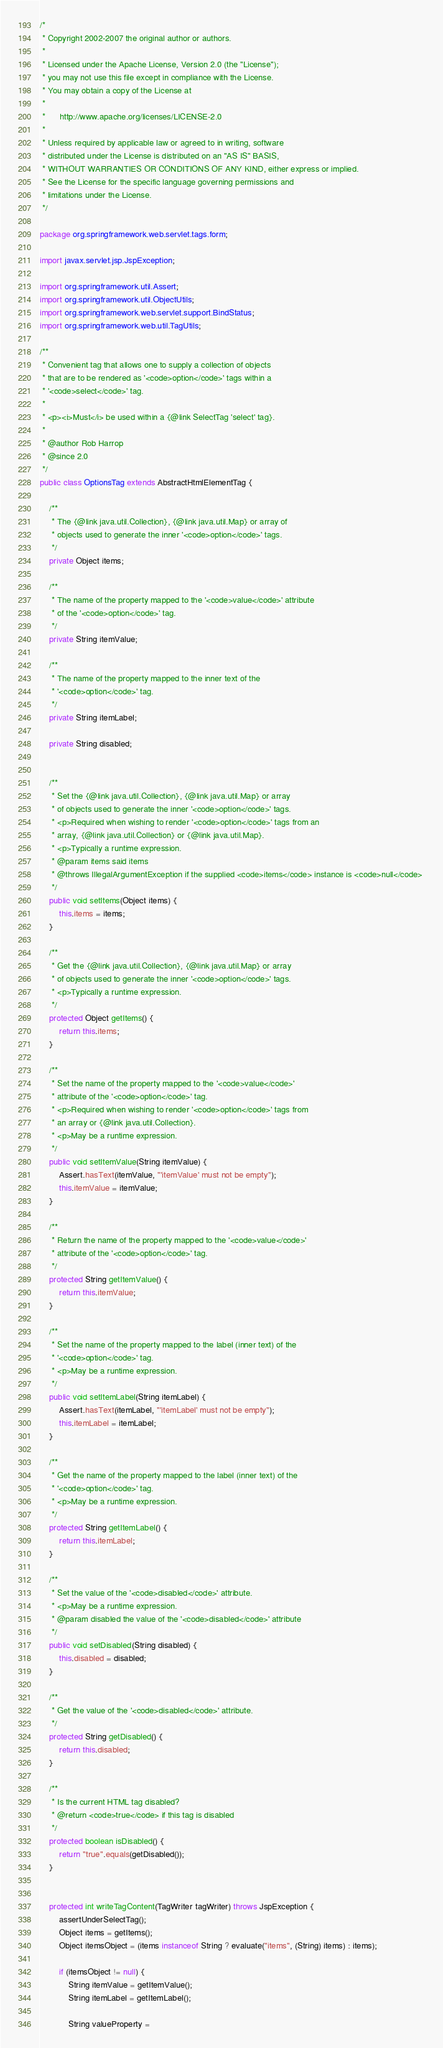<code> <loc_0><loc_0><loc_500><loc_500><_Java_>/*
 * Copyright 2002-2007 the original author or authors.
 *
 * Licensed under the Apache License, Version 2.0 (the "License");
 * you may not use this file except in compliance with the License.
 * You may obtain a copy of the License at
 *
 *      http://www.apache.org/licenses/LICENSE-2.0
 *
 * Unless required by applicable law or agreed to in writing, software
 * distributed under the License is distributed on an "AS IS" BASIS,
 * WITHOUT WARRANTIES OR CONDITIONS OF ANY KIND, either express or implied.
 * See the License for the specific language governing permissions and
 * limitations under the License.
 */

package org.springframework.web.servlet.tags.form;

import javax.servlet.jsp.JspException;

import org.springframework.util.Assert;
import org.springframework.util.ObjectUtils;
import org.springframework.web.servlet.support.BindStatus;
import org.springframework.web.util.TagUtils;

/**
 * Convenient tag that allows one to supply a collection of objects
 * that are to be rendered as '<code>option</code>' tags within a
 * '<code>select</code>' tag.
 * 
 * <p><i>Must</i> be used within a {@link SelectTag 'select' tag}.
 * 
 * @author Rob Harrop
 * @since 2.0
 */
public class OptionsTag extends AbstractHtmlElementTag {
	
	/**
	 * The {@link java.util.Collection}, {@link java.util.Map} or array of
	 * objects used to generate the inner '<code>option</code>' tags.
	 */
	private Object items;

	/**
	 * The name of the property mapped to the '<code>value</code>' attribute
	 * of the '<code>option</code>' tag.
	 */
	private String itemValue;

	/**
	 * The name of the property mapped to the inner text of the
	 * '<code>option</code>' tag.
	 */
	private String itemLabel;

	private String disabled;


	/**
	 * Set the {@link java.util.Collection}, {@link java.util.Map} or array
	 * of objects used to generate the inner '<code>option</code>' tags.
	 * <p>Required when wishing to render '<code>option</code>' tags from an
	 * array, {@link java.util.Collection} or {@link java.util.Map}.
	 * <p>Typically a runtime expression.
	 * @param items said items
	 * @throws IllegalArgumentException if the supplied <code>items</code> instance is <code>null</code> 
	 */
	public void setItems(Object items) {
		this.items = items;
	}

	/**
	 * Get the {@link java.util.Collection}, {@link java.util.Map} or array
	 * of objects used to generate the inner '<code>option</code>' tags.
	 * <p>Typically a runtime expression.
	 */
	protected Object getItems() {
		return this.items;
	}

	/**
	 * Set the name of the property mapped to the '<code>value</code>'
	 * attribute of the '<code>option</code>' tag.
	 * <p>Required when wishing to render '<code>option</code>' tags from
	 * an array or {@link java.util.Collection}.
	 * <p>May be a runtime expression.
	 */
	public void setItemValue(String itemValue) {
		Assert.hasText(itemValue, "'itemValue' must not be empty");
		this.itemValue = itemValue;
	}

	/**
	 * Return the name of the property mapped to the '<code>value</code>'
	 * attribute of the '<code>option</code>' tag.
	 */
	protected String getItemValue() {
		return this.itemValue;
	}

	/**
	 * Set the name of the property mapped to the label (inner text) of the
	 * '<code>option</code>' tag.
	 * <p>May be a runtime expression.
	 */
	public void setItemLabel(String itemLabel) {
		Assert.hasText(itemLabel, "'itemLabel' must not be empty");
		this.itemLabel = itemLabel;
	}

	/**
	 * Get the name of the property mapped to the label (inner text) of the
	 * '<code>option</code>' tag.
	 * <p>May be a runtime expression.
	 */
	protected String getItemLabel() {
		return this.itemLabel;
	}

	/**
	 * Set the value of the '<code>disabled</code>' attribute.
	 * <p>May be a runtime expression.
	 * @param disabled the value of the '<code>disabled</code>' attribute
	 */
	public void setDisabled(String disabled) {
		this.disabled = disabled;
	}

	/**
	 * Get the value of the '<code>disabled</code>' attribute.
	 */
	protected String getDisabled() {
		return this.disabled;
	}

	/**
	 * Is the current HTML tag disabled?
	 * @return <code>true</code> if this tag is disabled
	 */
	protected boolean isDisabled() {
		return "true".equals(getDisabled());
	}


	protected int writeTagContent(TagWriter tagWriter) throws JspException {
		assertUnderSelectTag();
		Object items = getItems();
		Object itemsObject = (items instanceof String ? evaluate("items", (String) items) : items);

		if (itemsObject != null) {
			String itemValue = getItemValue();
			String itemLabel = getItemLabel();

			String valueProperty =</code> 